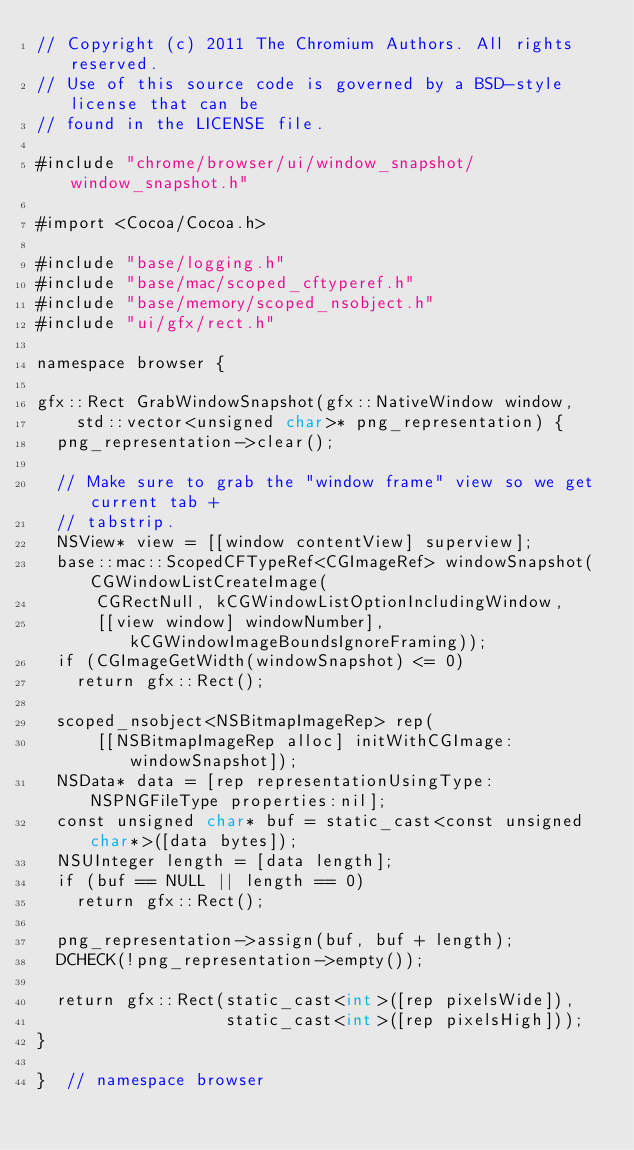Convert code to text. <code><loc_0><loc_0><loc_500><loc_500><_ObjectiveC_>// Copyright (c) 2011 The Chromium Authors. All rights reserved.
// Use of this source code is governed by a BSD-style license that can be
// found in the LICENSE file.

#include "chrome/browser/ui/window_snapshot/window_snapshot.h"

#import <Cocoa/Cocoa.h>

#include "base/logging.h"
#include "base/mac/scoped_cftyperef.h"
#include "base/memory/scoped_nsobject.h"
#include "ui/gfx/rect.h"

namespace browser {

gfx::Rect GrabWindowSnapshot(gfx::NativeWindow window,
    std::vector<unsigned char>* png_representation) {
  png_representation->clear();

  // Make sure to grab the "window frame" view so we get current tab +
  // tabstrip.
  NSView* view = [[window contentView] superview];
  base::mac::ScopedCFTypeRef<CGImageRef> windowSnapshot(CGWindowListCreateImage(
      CGRectNull, kCGWindowListOptionIncludingWindow,
      [[view window] windowNumber], kCGWindowImageBoundsIgnoreFraming));
  if (CGImageGetWidth(windowSnapshot) <= 0)
    return gfx::Rect();

  scoped_nsobject<NSBitmapImageRep> rep(
      [[NSBitmapImageRep alloc] initWithCGImage:windowSnapshot]);
  NSData* data = [rep representationUsingType:NSPNGFileType properties:nil];
  const unsigned char* buf = static_cast<const unsigned char*>([data bytes]);
  NSUInteger length = [data length];
  if (buf == NULL || length == 0)
    return gfx::Rect();

  png_representation->assign(buf, buf + length);
  DCHECK(!png_representation->empty());

  return gfx::Rect(static_cast<int>([rep pixelsWide]),
                   static_cast<int>([rep pixelsHigh]));
}

}  // namespace browser
</code> 